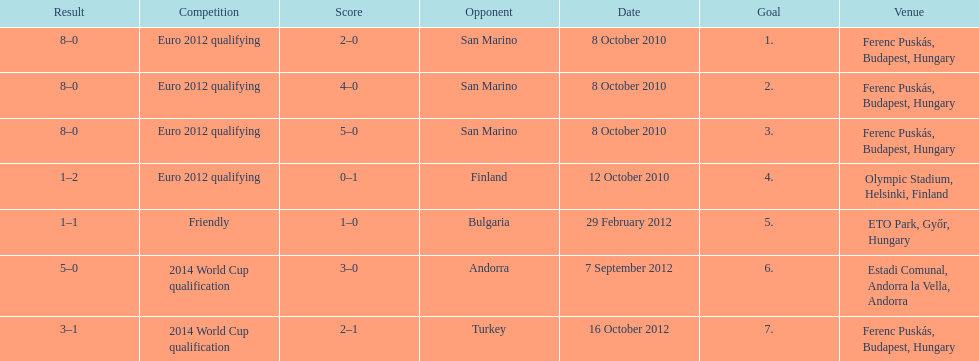How many non-qualifying games did he score in? 1. 